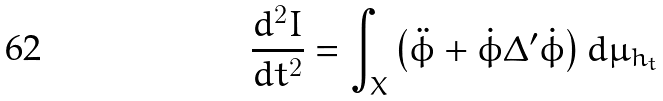<formula> <loc_0><loc_0><loc_500><loc_500>\frac { d ^ { 2 } I } { d t ^ { 2 } } = \int _ { X } \left ( \ddot { \phi } + \dot { \phi } \Delta ^ { \prime } \dot { \phi } \right ) d \mu _ { h _ { t } }</formula> 